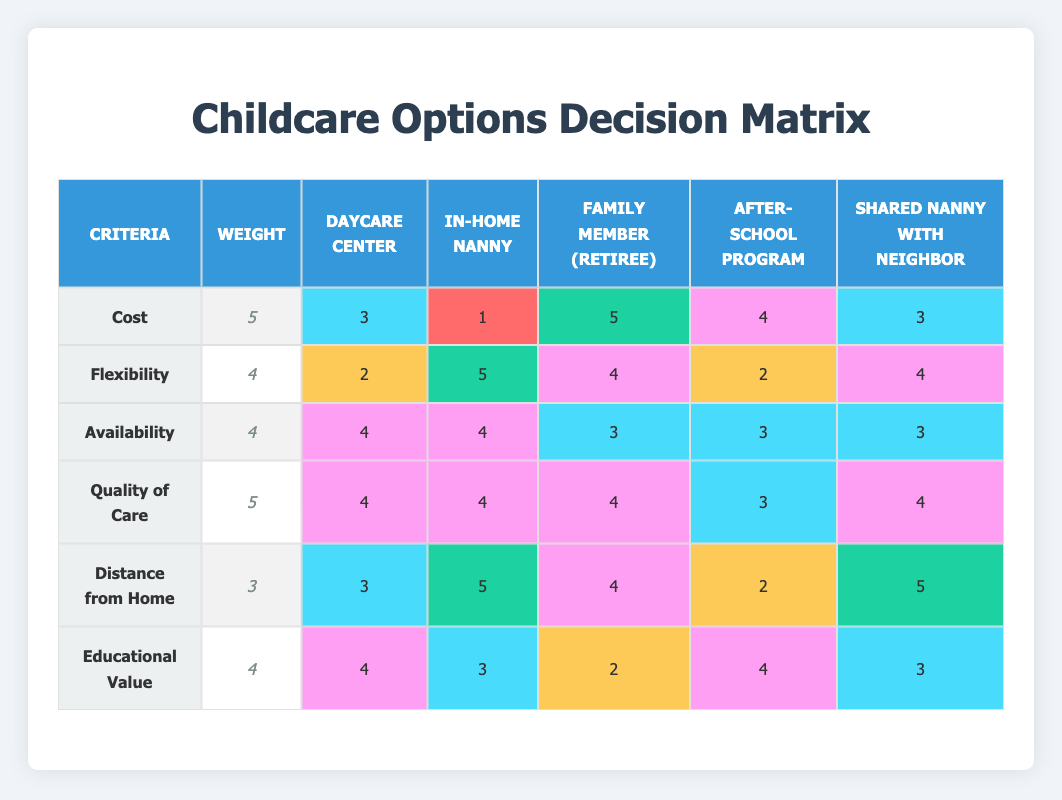What is the highest score for Cost among all options? The highest score for Cost is found by comparing the scores given to each childcare option under the Cost criterion. The scores are 3 for Daycare Center, 1 for In-Home Nanny, 5 for Family Member (Retiree), 4 for After-School Program, and 3 for Shared Nanny with Neighbor. The highest score is 5 for Family Member (Retiree).
Answer: 5 Which option has the lowest score for Flexibility? The Flexibility scores for each option are 2 for Daycare Center, 5 for In-Home Nanny, 4 for Family Member (Retiree), 2 for After-School Program, and 4 for Shared Nanny with Neighbor. By identifying the lowest score, we find that both Daycare Center and After-School Program have a score of 2, which is the lowest.
Answer: Daycare Center and After-School Program What is the total score for Quality of Care for In-Home Nanny? To get the total score for Quality of Care for In-Home Nanny, we refer only to the score in that row which is provided as 4. Since we're only looking for a single score, there is no need for further calculation.
Answer: 4 Is there any childcare option that has a perfect score in all criteria? We check each childcare option to see if any has a score of 5 in every criterion (Cost, Flexibility, Availability, Quality of Care, Distance from Home, and Educational Value). After reviewing, none have a perfect score of 5 in all criteria.
Answer: No What is the average score for Educational Value across all options? To find the average score for Educational Value, we first add the scores together: 4 for Daycare Center, 3 for In-Home Nanny, 2 for Family Member (Retiree), 4 for After-School Program, and 3 for Shared Nanny with Neighbor. This totals 16. There are 5 options, so we divide 16 by 5 to get the average. 16/5 = 3.2.
Answer: 3.2 Which childcare option has the highest total score across all criteria? For this, we need to calculate the total score for each option by adding together the scores from all criteria. By calculating: Daycare Center (3+2+4+4+3+4=20), In-Home Nanny (1+5+4+4+5+3=22), Family Member (Retiree) (5+4+3+4+4+2=22), After-School Program (4+2+3+3+2+4=18), and Shared Nanny with Neighbor (3+4+3+4+5+3=22). The highest total score is 22 which is shared by In-Home Nanny, Family Member (Retiree), and Shared Nanny with Neighbor.
Answer: In-Home Nanny, Family Member (Retiree), and Shared Nanny with Neighbor Are there any options with a score of 5 for Distance from Home? We can check the Distance from Home scores for each option: Daycare Center has a score of 3, In-Home Nanny has 5, Family Member (Retiree) has 4, After-School Program has 2, and Shared Nanny with Neighbor has 5. Both In-Home Nanny and Shared Nanny with Neighbor have a score of 5.
Answer: Yes, In-Home Nanny and Shared Nanny with Neighbor Which options score higher for Availability than the Daycare Center? We see that the Daycare Center has an Availability score of 4. Next, we look for options with scores in that criteria: In-Home Nanny has 4, Family Member (Retiree) has 3, After-School Program has 3, and Shared Nanny with Neighbor has 3. Only In-Home Nanny matches the score of 4 which is equal but none are higher.
Answer: In-Home Nanny 